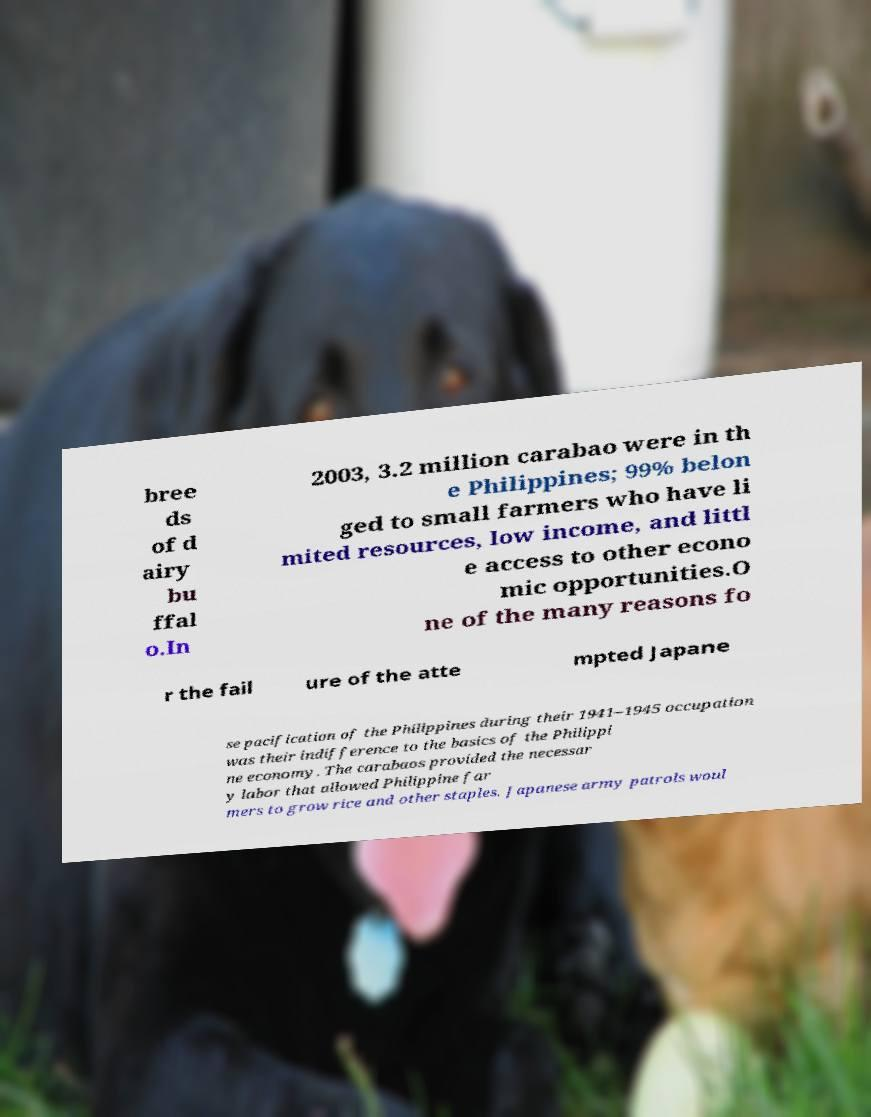I need the written content from this picture converted into text. Can you do that? bree ds of d airy bu ffal o.In 2003, 3.2 million carabao were in th e Philippines; 99% belon ged to small farmers who have li mited resources, low income, and littl e access to other econo mic opportunities.O ne of the many reasons fo r the fail ure of the atte mpted Japane se pacification of the Philippines during their 1941–1945 occupation was their indifference to the basics of the Philippi ne economy. The carabaos provided the necessar y labor that allowed Philippine far mers to grow rice and other staples. Japanese army patrols woul 